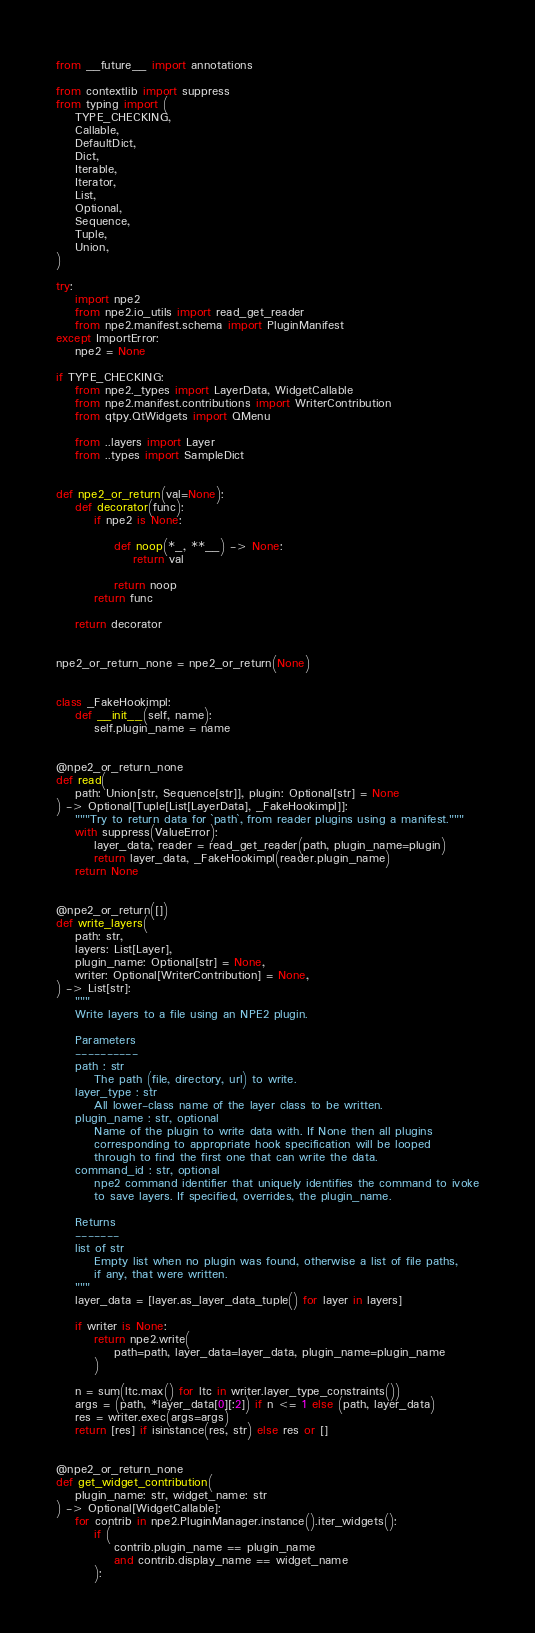<code> <loc_0><loc_0><loc_500><loc_500><_Python_>from __future__ import annotations

from contextlib import suppress
from typing import (
    TYPE_CHECKING,
    Callable,
    DefaultDict,
    Dict,
    Iterable,
    Iterator,
    List,
    Optional,
    Sequence,
    Tuple,
    Union,
)

try:
    import npe2
    from npe2.io_utils import read_get_reader
    from npe2.manifest.schema import PluginManifest
except ImportError:
    npe2 = None

if TYPE_CHECKING:
    from npe2._types import LayerData, WidgetCallable
    from npe2.manifest.contributions import WriterContribution
    from qtpy.QtWidgets import QMenu

    from ..layers import Layer
    from ..types import SampleDict


def npe2_or_return(val=None):
    def decorator(func):
        if npe2 is None:

            def noop(*_, **__) -> None:
                return val

            return noop
        return func

    return decorator


npe2_or_return_none = npe2_or_return(None)


class _FakeHookimpl:
    def __init__(self, name):
        self.plugin_name = name


@npe2_or_return_none
def read(
    path: Union[str, Sequence[str]], plugin: Optional[str] = None
) -> Optional[Tuple[List[LayerData], _FakeHookimpl]]:
    """Try to return data for `path`, from reader plugins using a manifest."""
    with suppress(ValueError):
        layer_data, reader = read_get_reader(path, plugin_name=plugin)
        return layer_data, _FakeHookimpl(reader.plugin_name)
    return None


@npe2_or_return([])
def write_layers(
    path: str,
    layers: List[Layer],
    plugin_name: Optional[str] = None,
    writer: Optional[WriterContribution] = None,
) -> List[str]:
    """
    Write layers to a file using an NPE2 plugin.

    Parameters
    ----------
    path : str
        The path (file, directory, url) to write.
    layer_type : str
        All lower-class name of the layer class to be written.
    plugin_name : str, optional
        Name of the plugin to write data with. If None then all plugins
        corresponding to appropriate hook specification will be looped
        through to find the first one that can write the data.
    command_id : str, optional
        npe2 command identifier that uniquely identifies the command to ivoke
        to save layers. If specified, overrides, the plugin_name.

    Returns
    -------
    list of str
        Empty list when no plugin was found, otherwise a list of file paths,
        if any, that were written.
    """
    layer_data = [layer.as_layer_data_tuple() for layer in layers]

    if writer is None:
        return npe2.write(
            path=path, layer_data=layer_data, plugin_name=plugin_name
        )

    n = sum(ltc.max() for ltc in writer.layer_type_constraints())
    args = (path, *layer_data[0][:2]) if n <= 1 else (path, layer_data)
    res = writer.exec(args=args)
    return [res] if isinstance(res, str) else res or []


@npe2_or_return_none
def get_widget_contribution(
    plugin_name: str, widget_name: str
) -> Optional[WidgetCallable]:
    for contrib in npe2.PluginManager.instance().iter_widgets():
        if (
            contrib.plugin_name == plugin_name
            and contrib.display_name == widget_name
        ):</code> 